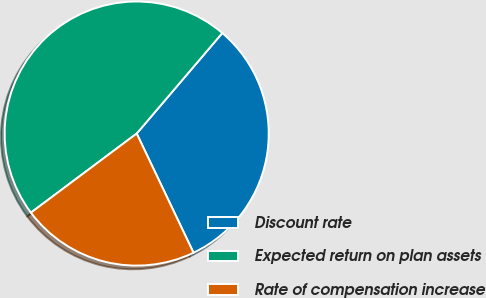Convert chart to OTSL. <chart><loc_0><loc_0><loc_500><loc_500><pie_chart><fcel>Discount rate<fcel>Expected return on plan assets<fcel>Rate of compensation increase<nl><fcel>31.69%<fcel>46.45%<fcel>21.86%<nl></chart> 